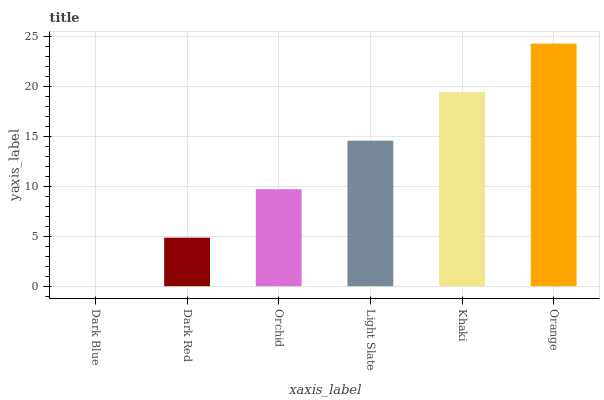Is Dark Blue the minimum?
Answer yes or no. Yes. Is Orange the maximum?
Answer yes or no. Yes. Is Dark Red the minimum?
Answer yes or no. No. Is Dark Red the maximum?
Answer yes or no. No. Is Dark Red greater than Dark Blue?
Answer yes or no. Yes. Is Dark Blue less than Dark Red?
Answer yes or no. Yes. Is Dark Blue greater than Dark Red?
Answer yes or no. No. Is Dark Red less than Dark Blue?
Answer yes or no. No. Is Light Slate the high median?
Answer yes or no. Yes. Is Orchid the low median?
Answer yes or no. Yes. Is Khaki the high median?
Answer yes or no. No. Is Orange the low median?
Answer yes or no. No. 